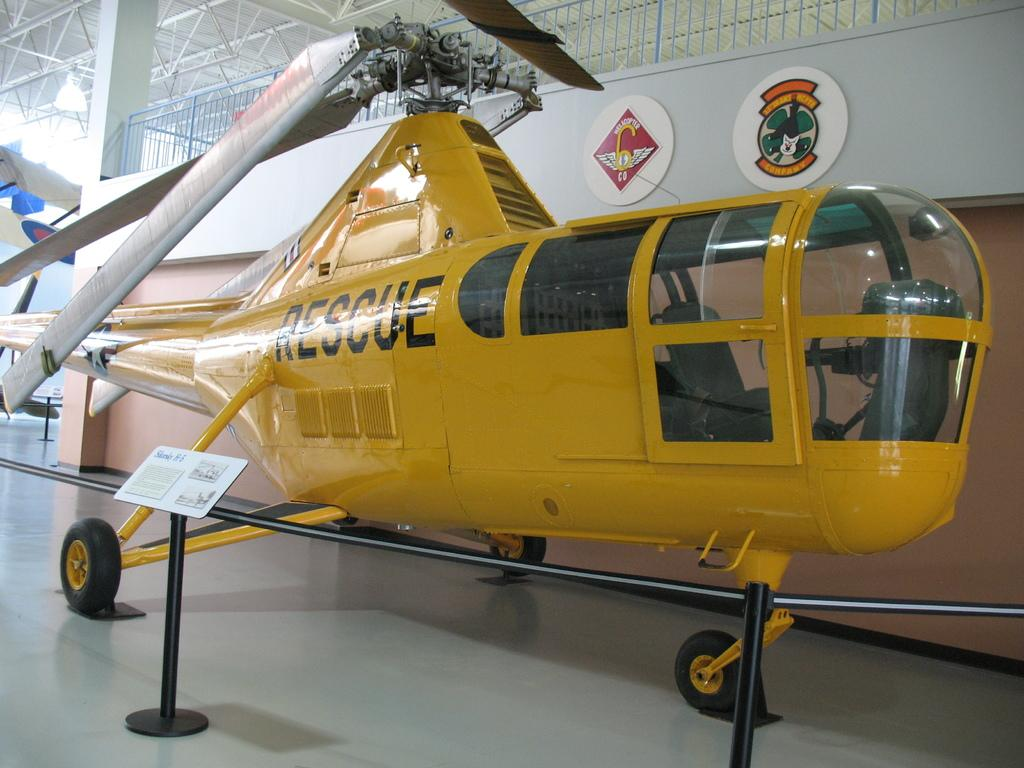Provide a one-sentence caption for the provided image. A resuce plane parked inside of a building. 